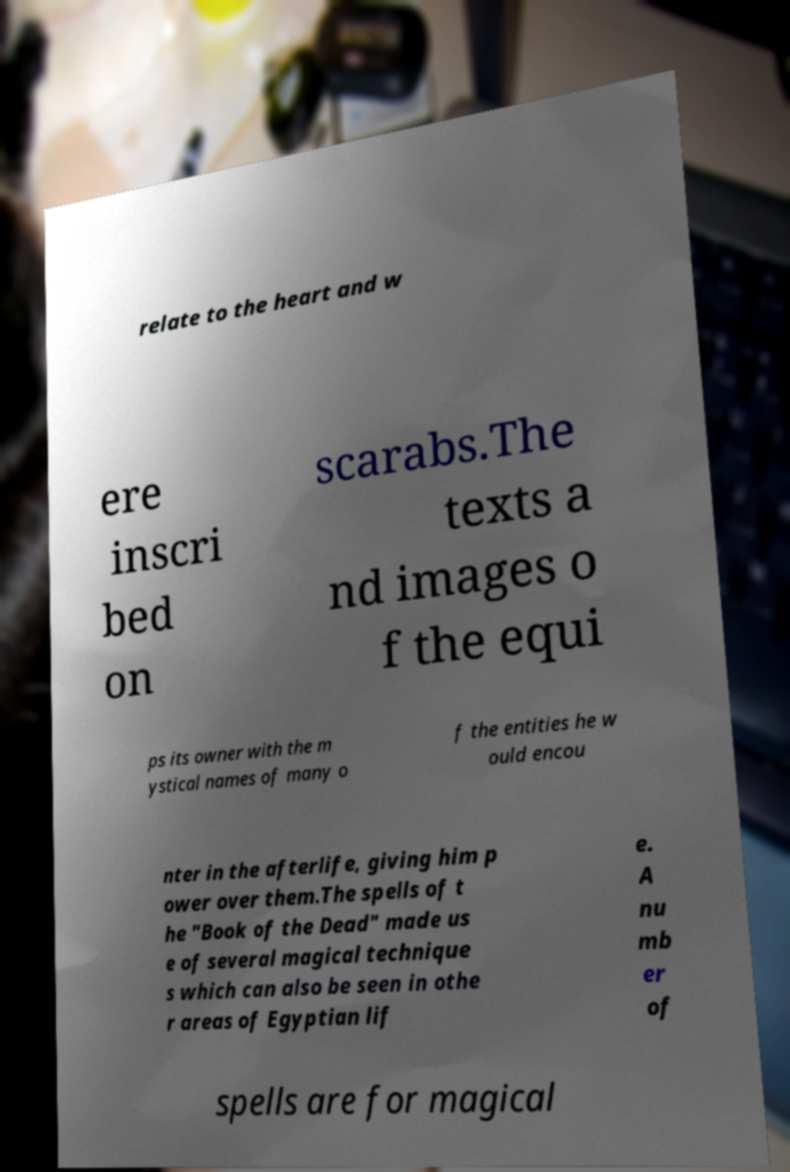I need the written content from this picture converted into text. Can you do that? relate to the heart and w ere inscri bed on scarabs.The texts a nd images o f the equi ps its owner with the m ystical names of many o f the entities he w ould encou nter in the afterlife, giving him p ower over them.The spells of t he "Book of the Dead" made us e of several magical technique s which can also be seen in othe r areas of Egyptian lif e. A nu mb er of spells are for magical 